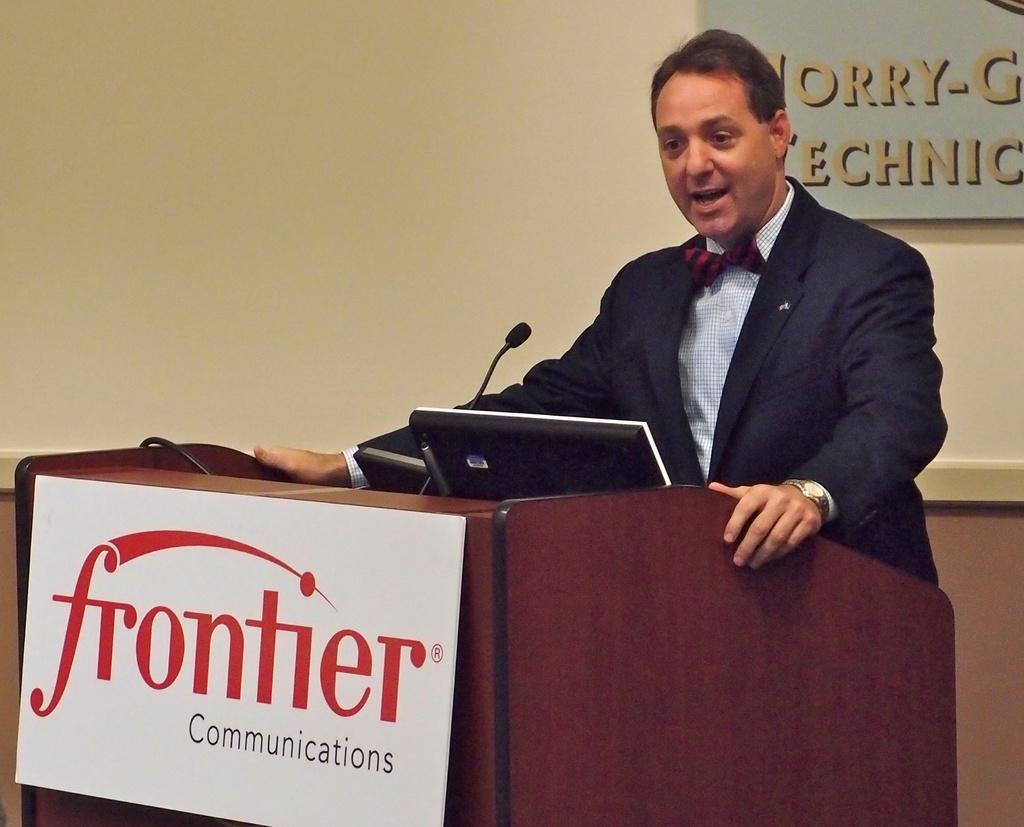Please provide a concise description of this image. In this image, we can see a man standing and wearing a coat and a tie and there is a monitor and a mic on the podium and we can see a board. In the background, there is a board with some text on the wall. 